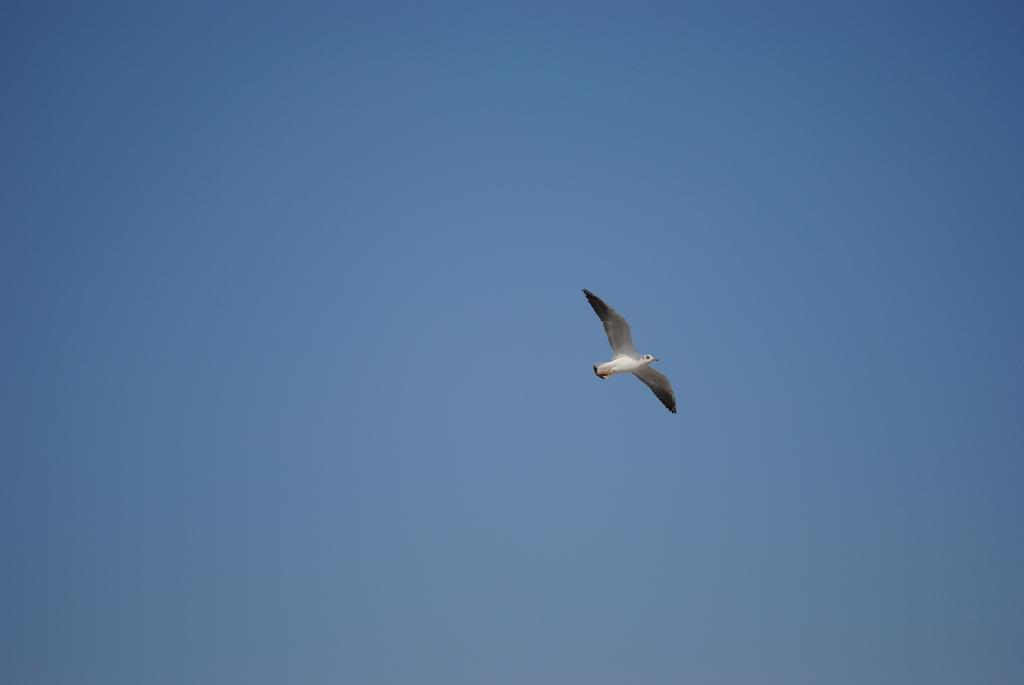What type of animal can be seen in the image? There is a bird in the image. What is the bird doing in the image? The bird is flying. What can be seen in the background of the image? The sky is visible behind the bird. What type of wrench is the bird using to fly in the image? There is no wrench present in the image, and birds do not use wrenches to fly. 